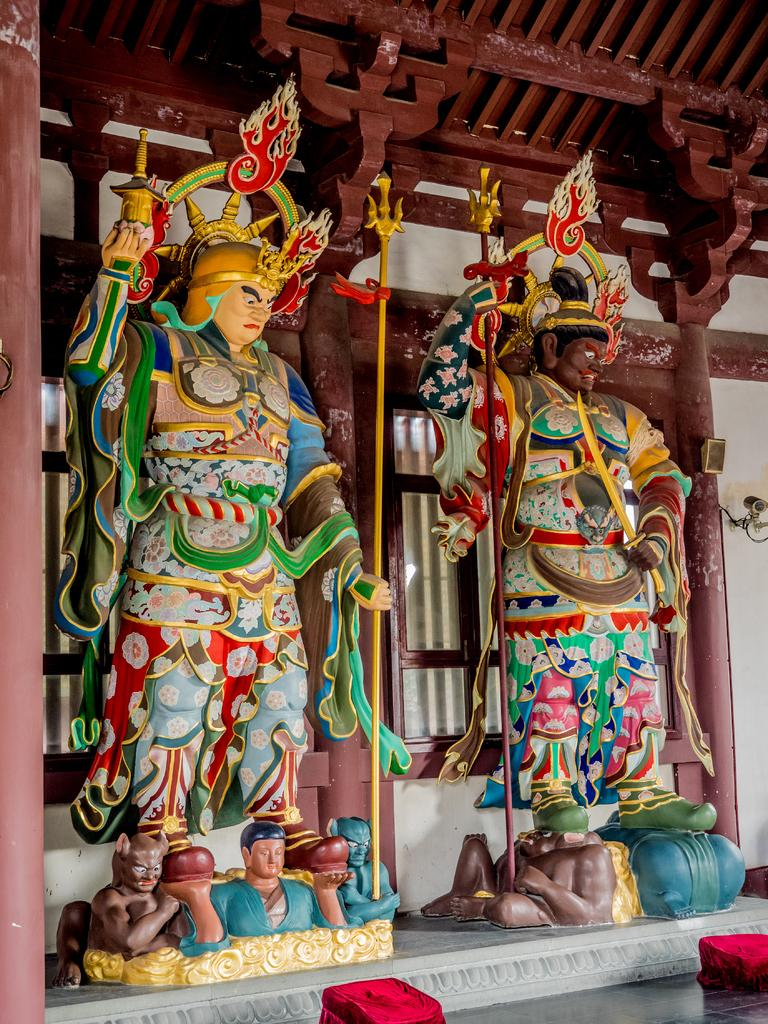What type of structures are present in the image? There are statues and pillars in the image. What architectural feature can be seen in the image? There is a wall visible in the image. What might provide natural light in the image? There are windows in the image. What type of nail is being used to celebrate a birthday in the image? There is no nail or birthday celebration present in the image. What type of work is being done on the statues in the image? There is no work being done on the statues in the image; they are stationary structures. 